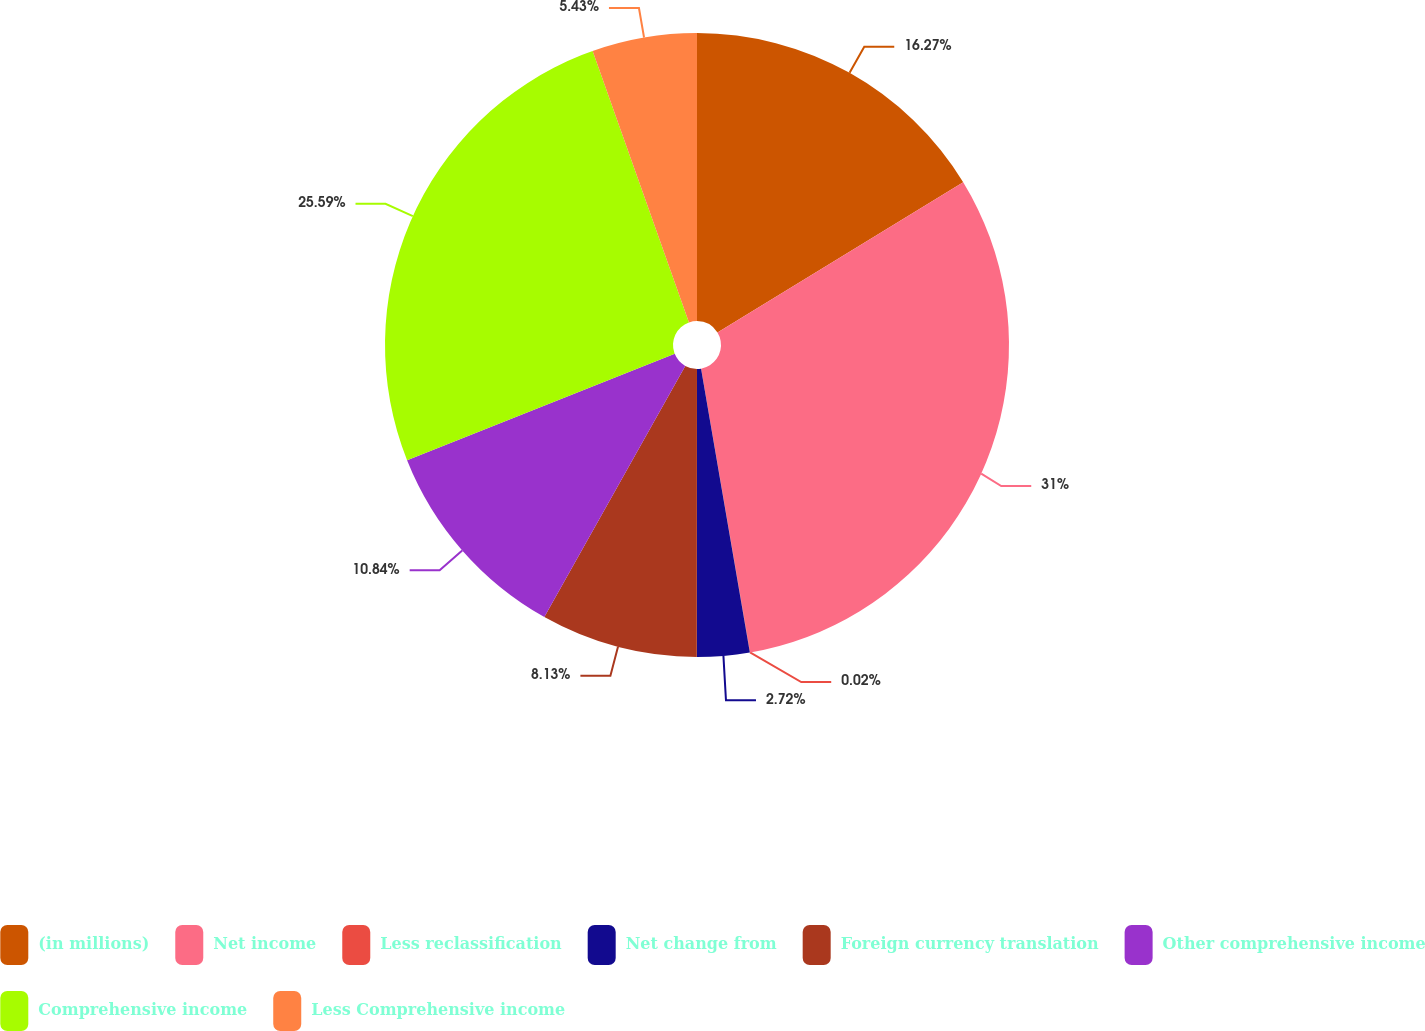Convert chart. <chart><loc_0><loc_0><loc_500><loc_500><pie_chart><fcel>(in millions)<fcel>Net income<fcel>Less reclassification<fcel>Net change from<fcel>Foreign currency translation<fcel>Other comprehensive income<fcel>Comprehensive income<fcel>Less Comprehensive income<nl><fcel>16.27%<fcel>31.01%<fcel>0.02%<fcel>2.72%<fcel>8.13%<fcel>10.84%<fcel>25.6%<fcel>5.43%<nl></chart> 